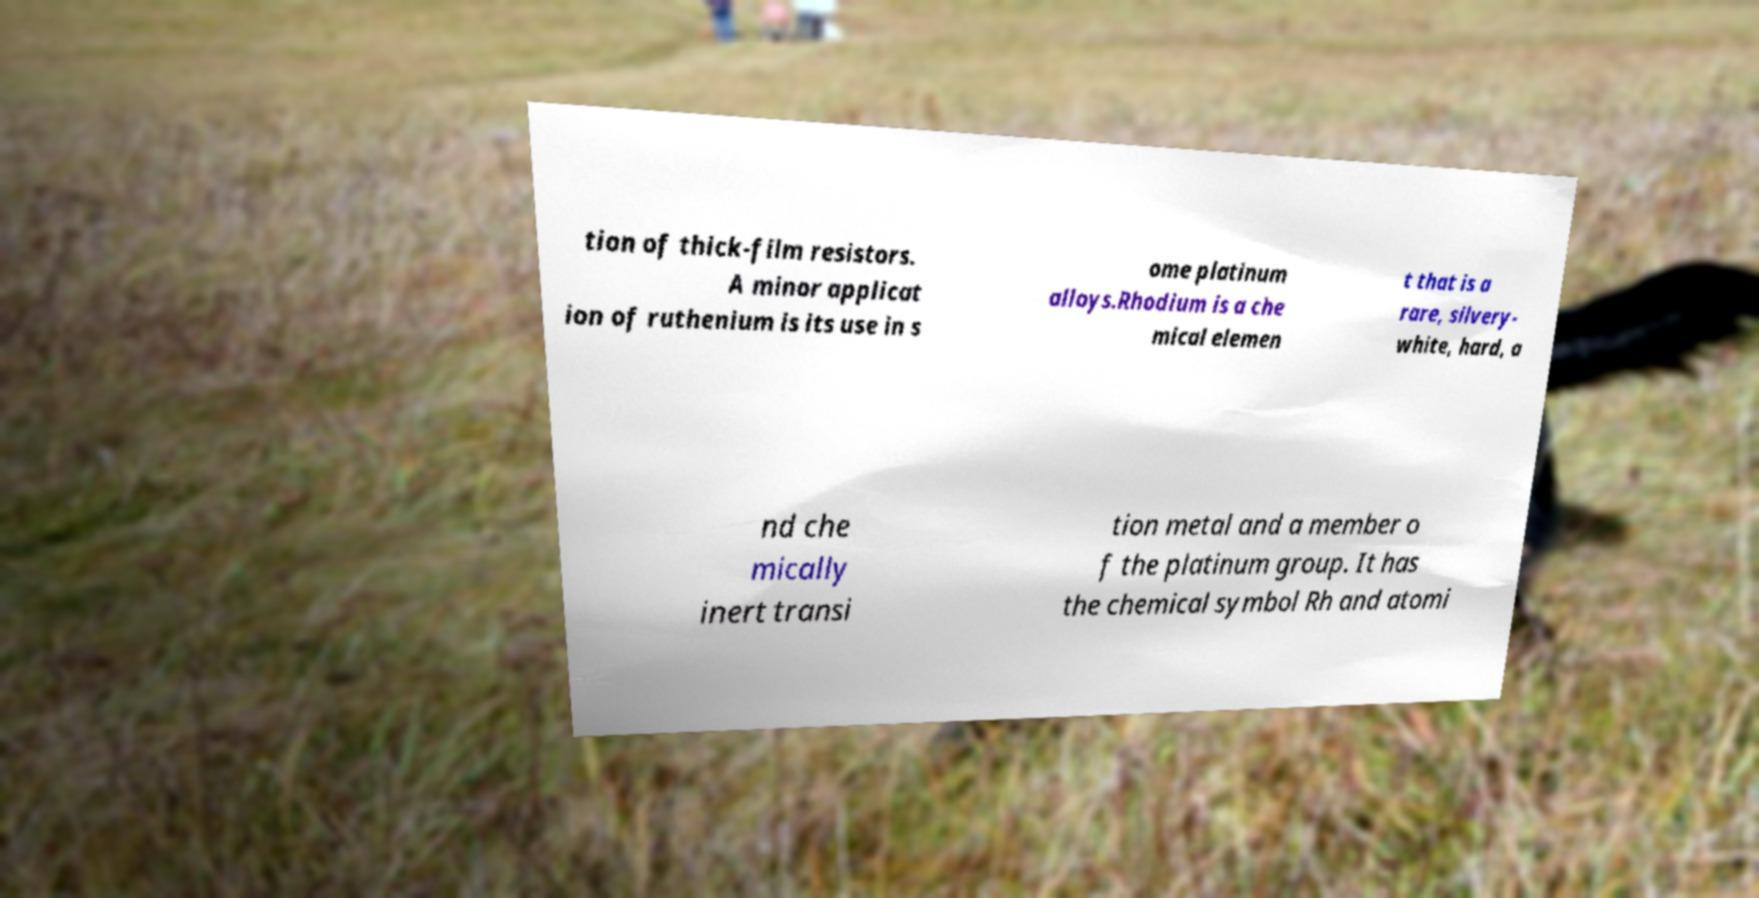There's text embedded in this image that I need extracted. Can you transcribe it verbatim? tion of thick-film resistors. A minor applicat ion of ruthenium is its use in s ome platinum alloys.Rhodium is a che mical elemen t that is a rare, silvery- white, hard, a nd che mically inert transi tion metal and a member o f the platinum group. It has the chemical symbol Rh and atomi 